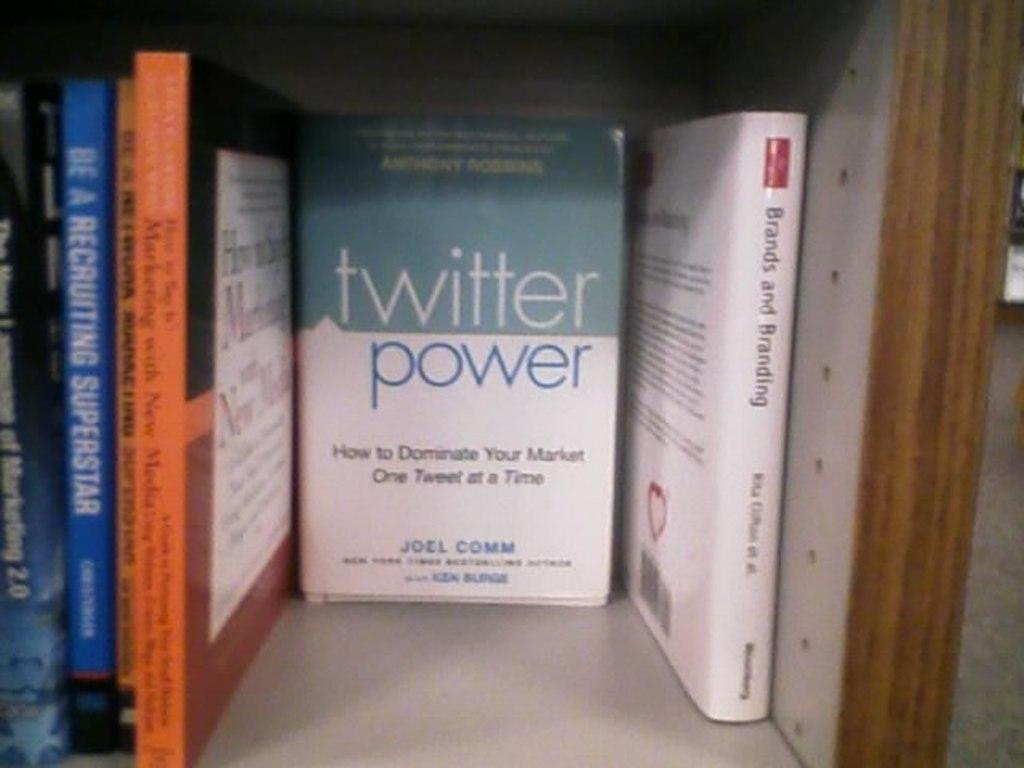<image>
Present a compact description of the photo's key features. Book named Twitter Power by Joel Comm on a book shelf. 